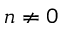Convert formula to latex. <formula><loc_0><loc_0><loc_500><loc_500>n \neq 0</formula> 